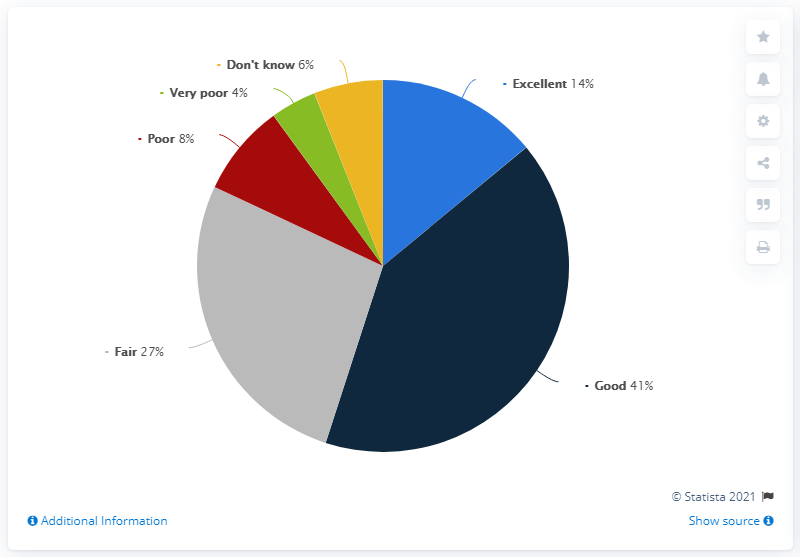Give some essential details in this illustration. The biggest colored segment is navy blue. The quotient obtained when the Good opinion percent is divided by the average opinion percent is 2.46 